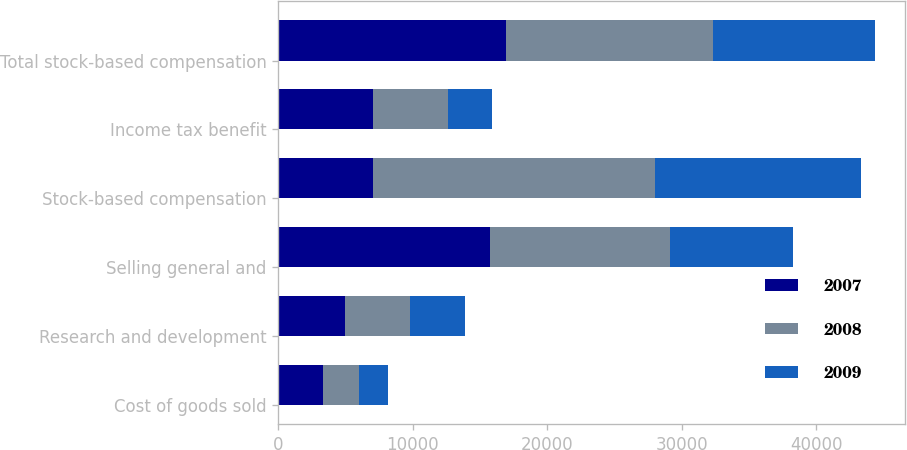Convert chart. <chart><loc_0><loc_0><loc_500><loc_500><stacked_bar_chart><ecel><fcel>Cost of goods sold<fcel>Research and development<fcel>Selling general and<fcel>Stock-based compensation<fcel>Income tax benefit<fcel>Total stock-based compensation<nl><fcel>2007<fcel>3297<fcel>4943<fcel>15715<fcel>7011<fcel>7011<fcel>16944<nl><fcel>2008<fcel>2721<fcel>4882<fcel>13371<fcel>20974<fcel>5589<fcel>15385<nl><fcel>2009<fcel>2124<fcel>4033<fcel>9159<fcel>15316<fcel>3286<fcel>12030<nl></chart> 